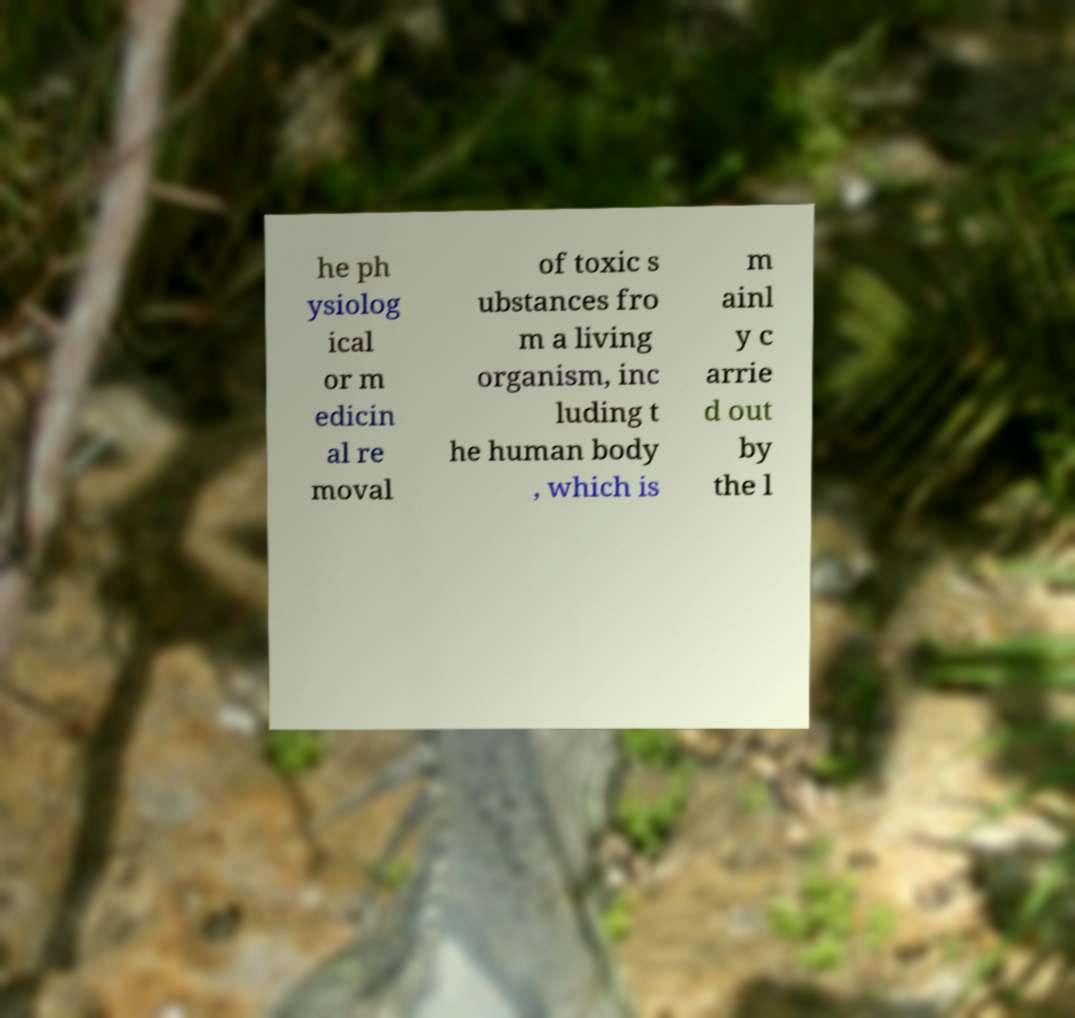Could you assist in decoding the text presented in this image and type it out clearly? he ph ysiolog ical or m edicin al re moval of toxic s ubstances fro m a living organism, inc luding t he human body , which is m ainl y c arrie d out by the l 